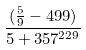Convert formula to latex. <formula><loc_0><loc_0><loc_500><loc_500>\frac { ( \frac { 5 } { 9 } - 4 9 9 ) } { 5 + 3 5 7 ^ { 2 2 9 } }</formula> 